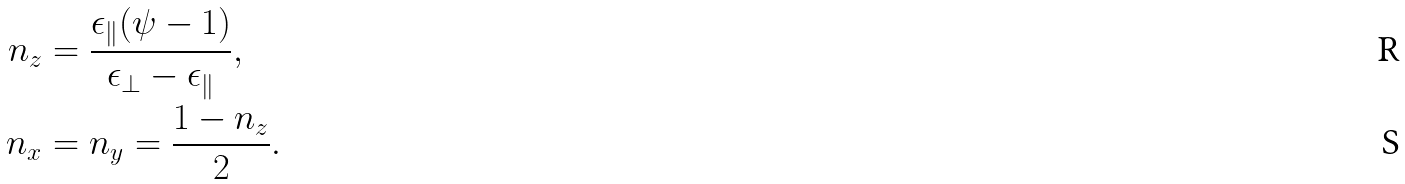Convert formula to latex. <formula><loc_0><loc_0><loc_500><loc_500>n _ { z } & = \frac { \epsilon _ { \| } ( \psi - 1 ) } { \epsilon _ { \perp } - \epsilon _ { \| } } , \\ n _ { x } & = n _ { y } = \frac { 1 - n _ { z } } { 2 } .</formula> 